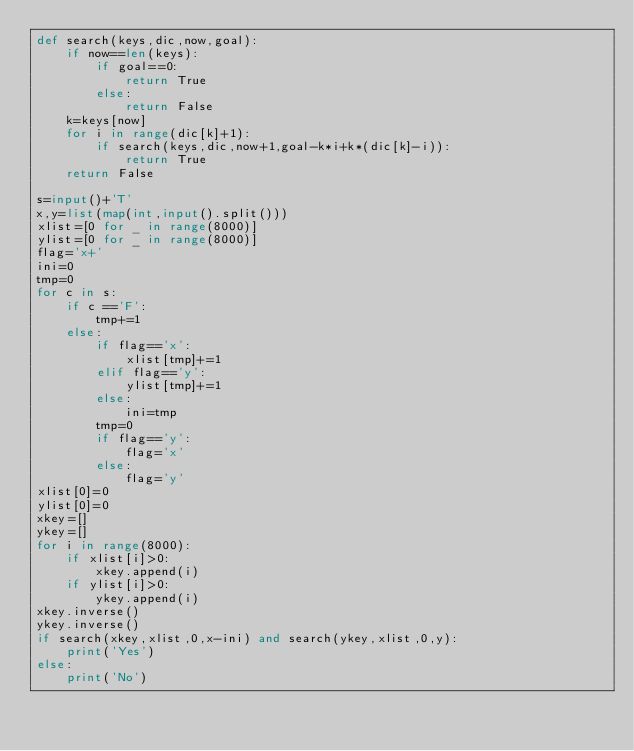Convert code to text. <code><loc_0><loc_0><loc_500><loc_500><_Python_>def search(keys,dic,now,goal):
    if now==len(keys):
        if goal==0:
            return True
        else:
            return False
    k=keys[now]
    for i in range(dic[k]+1):
        if search(keys,dic,now+1,goal-k*i+k*(dic[k]-i)):
            return True
    return False

s=input()+'T'
x,y=list(map(int,input().split()))
xlist=[0 for _ in range(8000)]
ylist=[0 for _ in range(8000)]
flag='x+'
ini=0
tmp=0
for c in s:
    if c =='F':
        tmp+=1
    else:
        if flag=='x':
            xlist[tmp]+=1
        elif flag=='y':
            ylist[tmp]+=1
        else:
            ini=tmp
        tmp=0
        if flag=='y':
            flag='x'
        else:
            flag='y'
xlist[0]=0
ylist[0]=0
xkey=[]
ykey=[]
for i in range(8000):
    if xlist[i]>0:
        xkey.append(i)
    if ylist[i]>0:
        ykey.append(i)
xkey.inverse()
ykey.inverse()
if search(xkey,xlist,0,x-ini) and search(ykey,xlist,0,y):
    print('Yes')
else:
    print('No')
</code> 